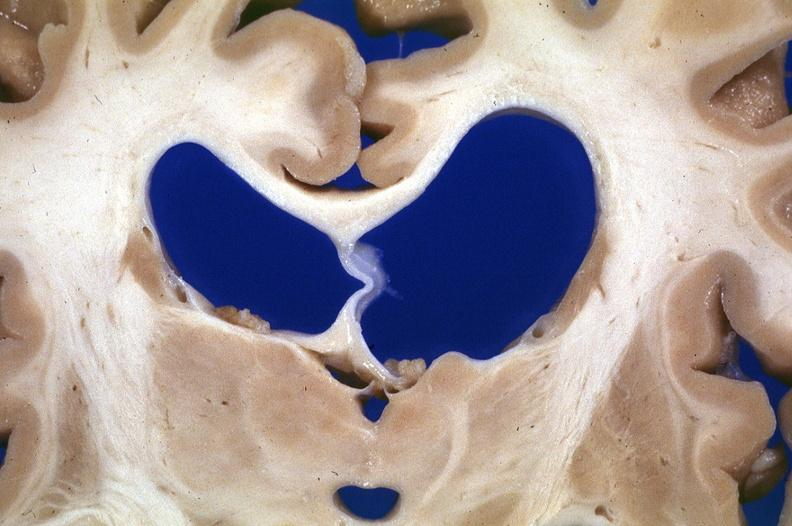does close-up of lesion show brain, frontal lobe atrophy, pick 's disease?
Answer the question using a single word or phrase. No 